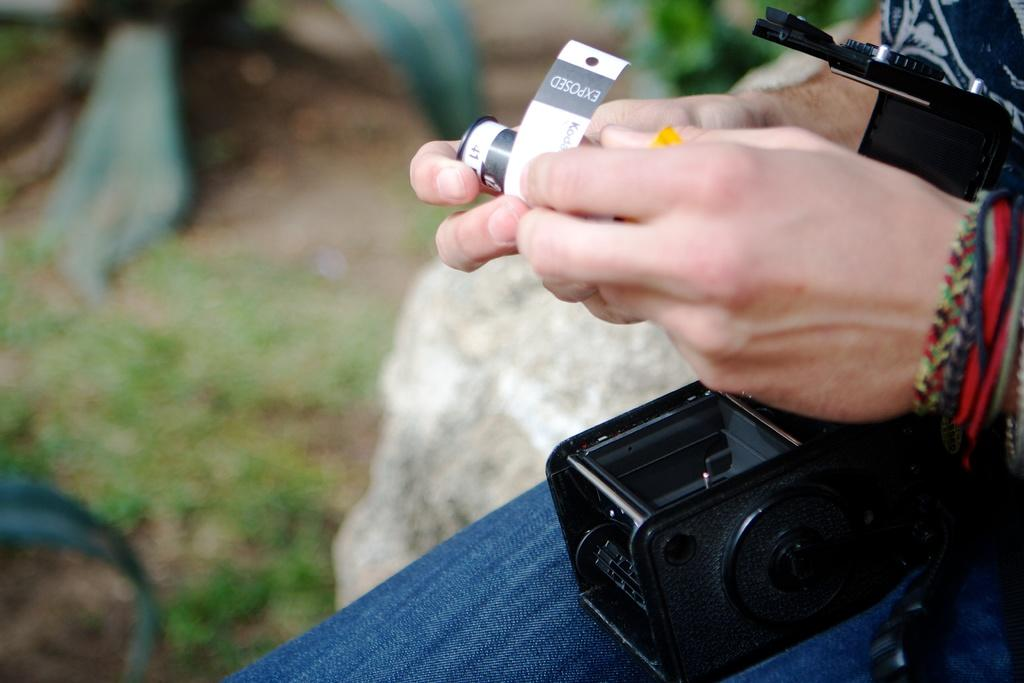What is the main subject of the image? There is a person in the image. What is the person holding in the image? The person is holding a camera film. What object is on the person's lap? There is a camera on the person's lap. Can you describe the background of the image? The background of the image is blurry. How many snails can be seen attacking the person in the image? There are no snails present in the image, and therefore no attack can be observed. 